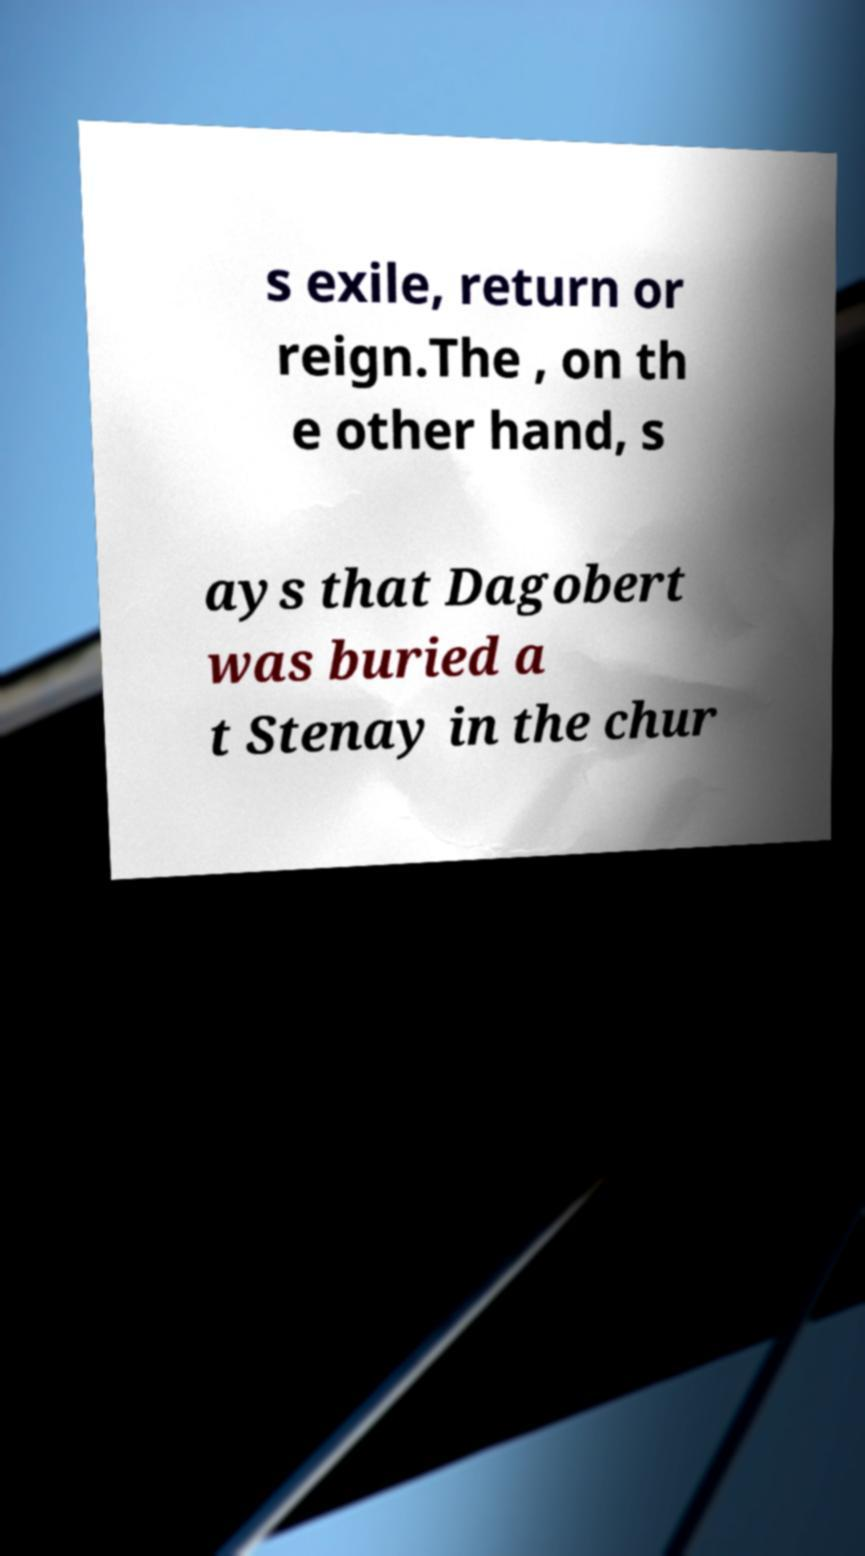For documentation purposes, I need the text within this image transcribed. Could you provide that? s exile, return or reign.The , on th e other hand, s ays that Dagobert was buried a t Stenay in the chur 